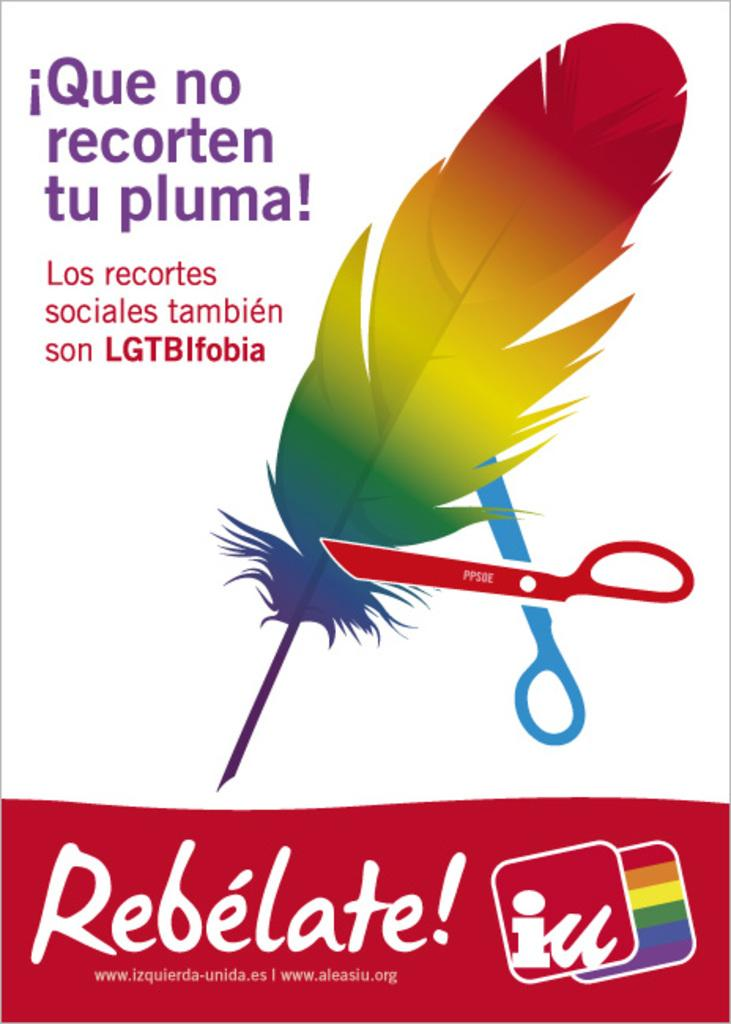Provide a one-sentence caption for the provided image. An advertisement supporting LGTB issues shows a pair of scissors attempting to cut a rainbow feather. 